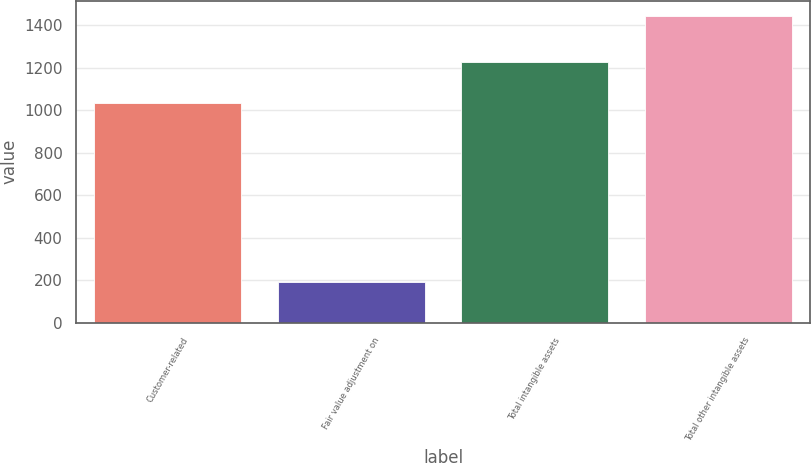Convert chart. <chart><loc_0><loc_0><loc_500><loc_500><bar_chart><fcel>Customer-related<fcel>Fair value adjustment on<fcel>Total intangible assets<fcel>Total other intangible assets<nl><fcel>1036<fcel>191<fcel>1227<fcel>1443<nl></chart> 